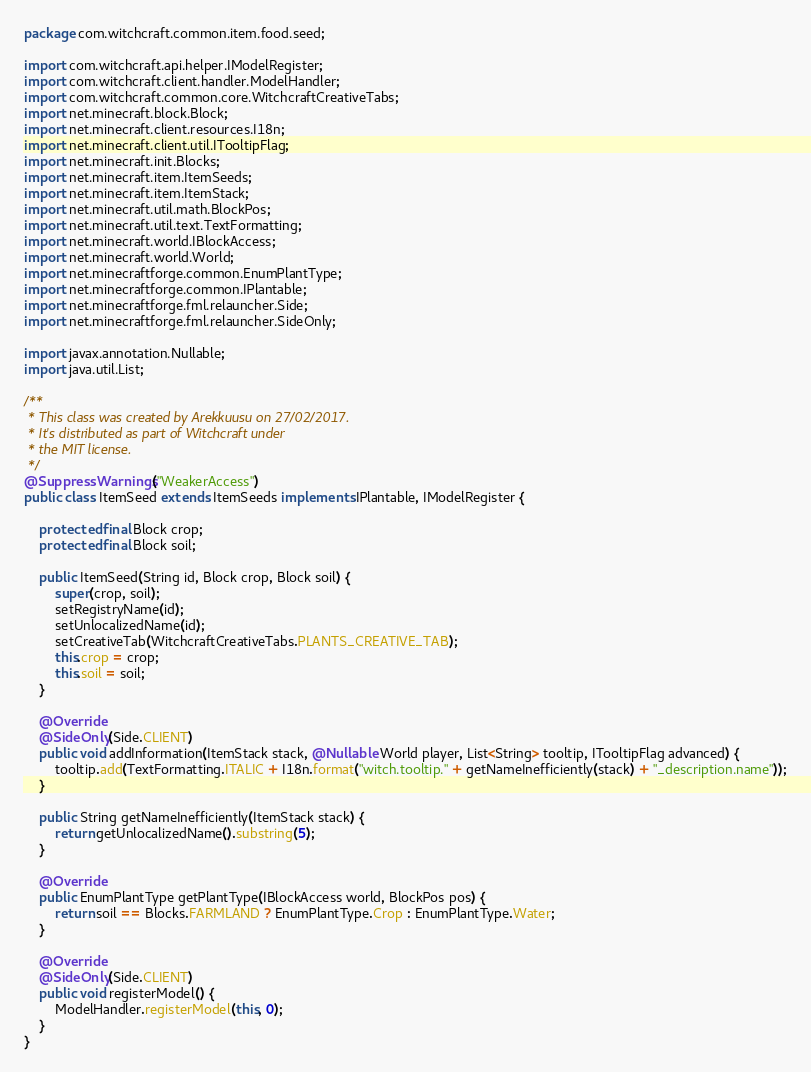Convert code to text. <code><loc_0><loc_0><loc_500><loc_500><_Java_>package com.witchcraft.common.item.food.seed;

import com.witchcraft.api.helper.IModelRegister;
import com.witchcraft.client.handler.ModelHandler;
import com.witchcraft.common.core.WitchcraftCreativeTabs;
import net.minecraft.block.Block;
import net.minecraft.client.resources.I18n;
import net.minecraft.client.util.ITooltipFlag;
import net.minecraft.init.Blocks;
import net.minecraft.item.ItemSeeds;
import net.minecraft.item.ItemStack;
import net.minecraft.util.math.BlockPos;
import net.minecraft.util.text.TextFormatting;
import net.minecraft.world.IBlockAccess;
import net.minecraft.world.World;
import net.minecraftforge.common.EnumPlantType;
import net.minecraftforge.common.IPlantable;
import net.minecraftforge.fml.relauncher.Side;
import net.minecraftforge.fml.relauncher.SideOnly;

import javax.annotation.Nullable;
import java.util.List;

/**
 * This class was created by Arekkuusu on 27/02/2017.
 * It's distributed as part of Witchcraft under
 * the MIT license.
 */
@SuppressWarnings("WeakerAccess")
public class ItemSeed extends ItemSeeds implements IPlantable, IModelRegister {

	protected final Block crop;
	protected final Block soil;

	public ItemSeed(String id, Block crop, Block soil) {
		super(crop, soil);
		setRegistryName(id);
		setUnlocalizedName(id);
		setCreativeTab(WitchcraftCreativeTabs.PLANTS_CREATIVE_TAB);
		this.crop = crop;
		this.soil = soil;
	}

	@Override
	@SideOnly(Side.CLIENT)
	public void addInformation(ItemStack stack, @Nullable World player, List<String> tooltip, ITooltipFlag advanced) {
		tooltip.add(TextFormatting.ITALIC + I18n.format("witch.tooltip." + getNameInefficiently(stack) + "_description.name"));
	}

	public String getNameInefficiently(ItemStack stack) {
		return getUnlocalizedName().substring(5);
	}

	@Override
	public EnumPlantType getPlantType(IBlockAccess world, BlockPos pos) {
		return soil == Blocks.FARMLAND ? EnumPlantType.Crop : EnumPlantType.Water;
	}

	@Override
	@SideOnly(Side.CLIENT)
	public void registerModel() {
		ModelHandler.registerModel(this, 0);
	}
}
</code> 